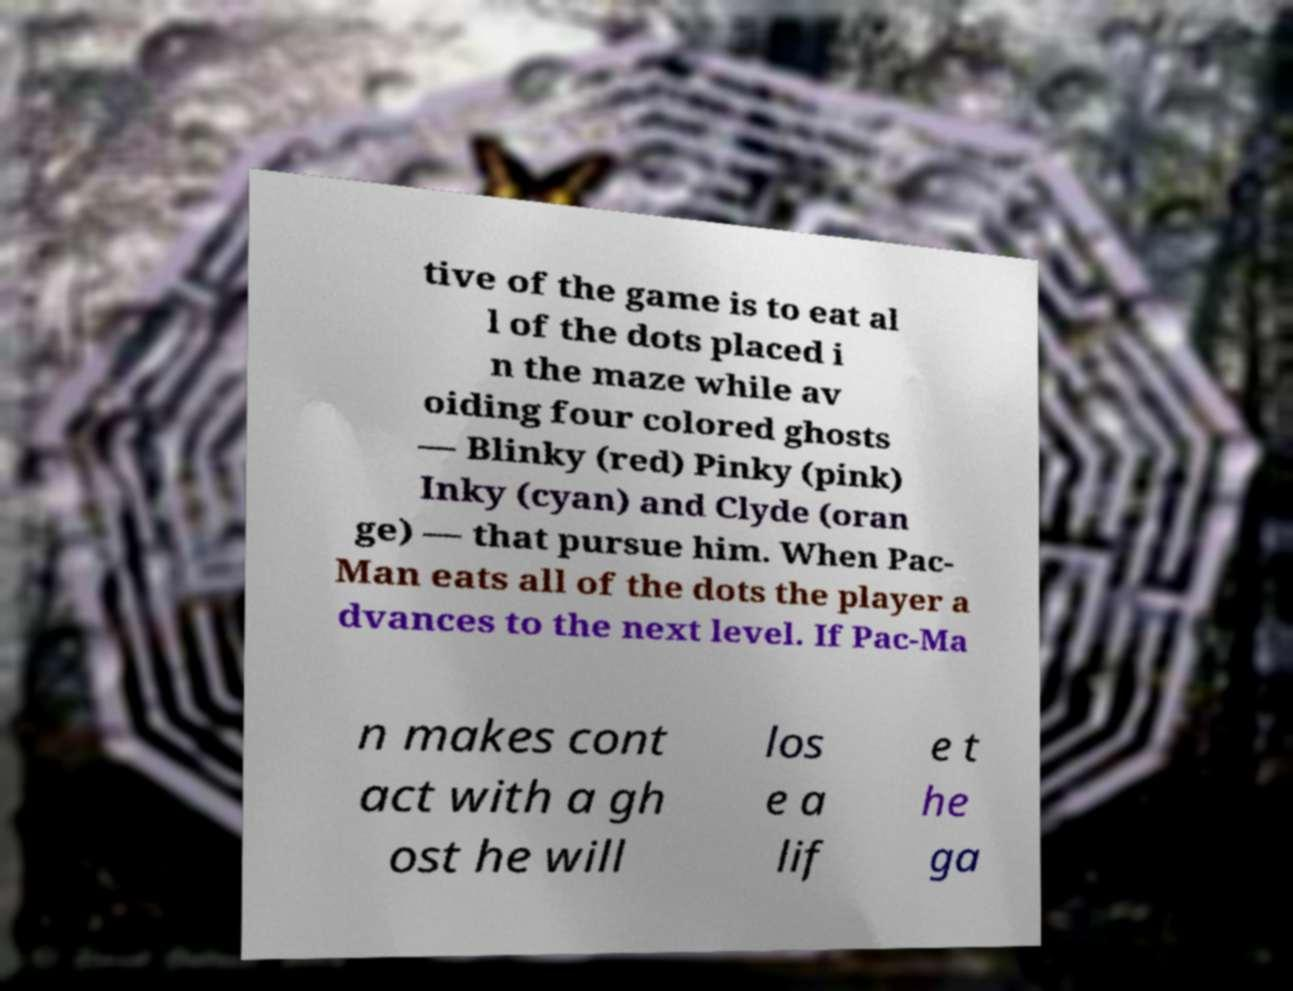What messages or text are displayed in this image? I need them in a readable, typed format. tive of the game is to eat al l of the dots placed i n the maze while av oiding four colored ghosts — Blinky (red) Pinky (pink) Inky (cyan) and Clyde (oran ge) — that pursue him. When Pac- Man eats all of the dots the player a dvances to the next level. If Pac-Ma n makes cont act with a gh ost he will los e a lif e t he ga 